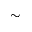Convert formula to latex. <formula><loc_0><loc_0><loc_500><loc_500>{ \sim }</formula> 